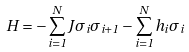<formula> <loc_0><loc_0><loc_500><loc_500>H = - \sum _ { i = 1 } ^ { N } J \sigma _ { i } \sigma _ { i + 1 } - \sum _ { i = 1 } ^ { N } h _ { i } \sigma _ { i }</formula> 